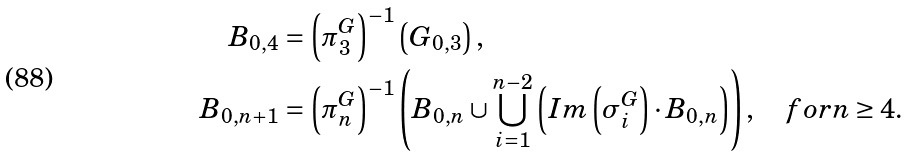Convert formula to latex. <formula><loc_0><loc_0><loc_500><loc_500>B _ { 0 , 4 } & = \left ( \pi ^ { G } _ { 3 } \right ) ^ { - 1 } \left ( G _ { 0 , 3 } \right ) , \\ B _ { 0 , n + 1 } & = \left ( \pi ^ { G } _ { n } \right ) ^ { - 1 } \left ( B _ { 0 , n } \cup \bigcup _ { i = 1 } ^ { n - 2 } \left ( I m \left ( \sigma ^ { G } _ { i } \right ) \cdot B _ { 0 , n } \right ) \right ) , \quad f o r n \geq 4 .</formula> 